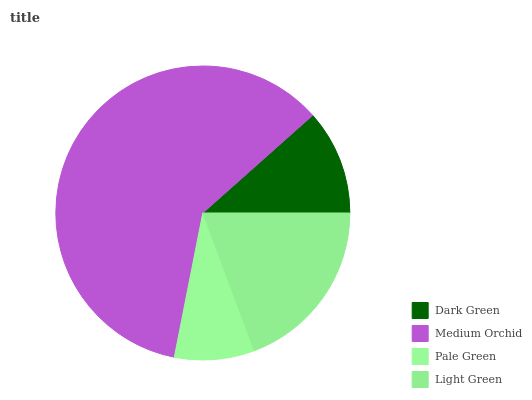Is Pale Green the minimum?
Answer yes or no. Yes. Is Medium Orchid the maximum?
Answer yes or no. Yes. Is Medium Orchid the minimum?
Answer yes or no. No. Is Pale Green the maximum?
Answer yes or no. No. Is Medium Orchid greater than Pale Green?
Answer yes or no. Yes. Is Pale Green less than Medium Orchid?
Answer yes or no. Yes. Is Pale Green greater than Medium Orchid?
Answer yes or no. No. Is Medium Orchid less than Pale Green?
Answer yes or no. No. Is Light Green the high median?
Answer yes or no. Yes. Is Dark Green the low median?
Answer yes or no. Yes. Is Dark Green the high median?
Answer yes or no. No. Is Light Green the low median?
Answer yes or no. No. 